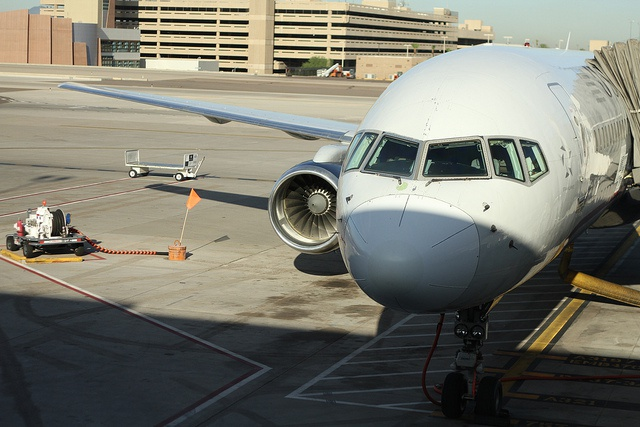Describe the objects in this image and their specific colors. I can see a airplane in darkgray, ivory, black, and gray tones in this image. 